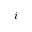Convert formula to latex. <formula><loc_0><loc_0><loc_500><loc_500>i</formula> 